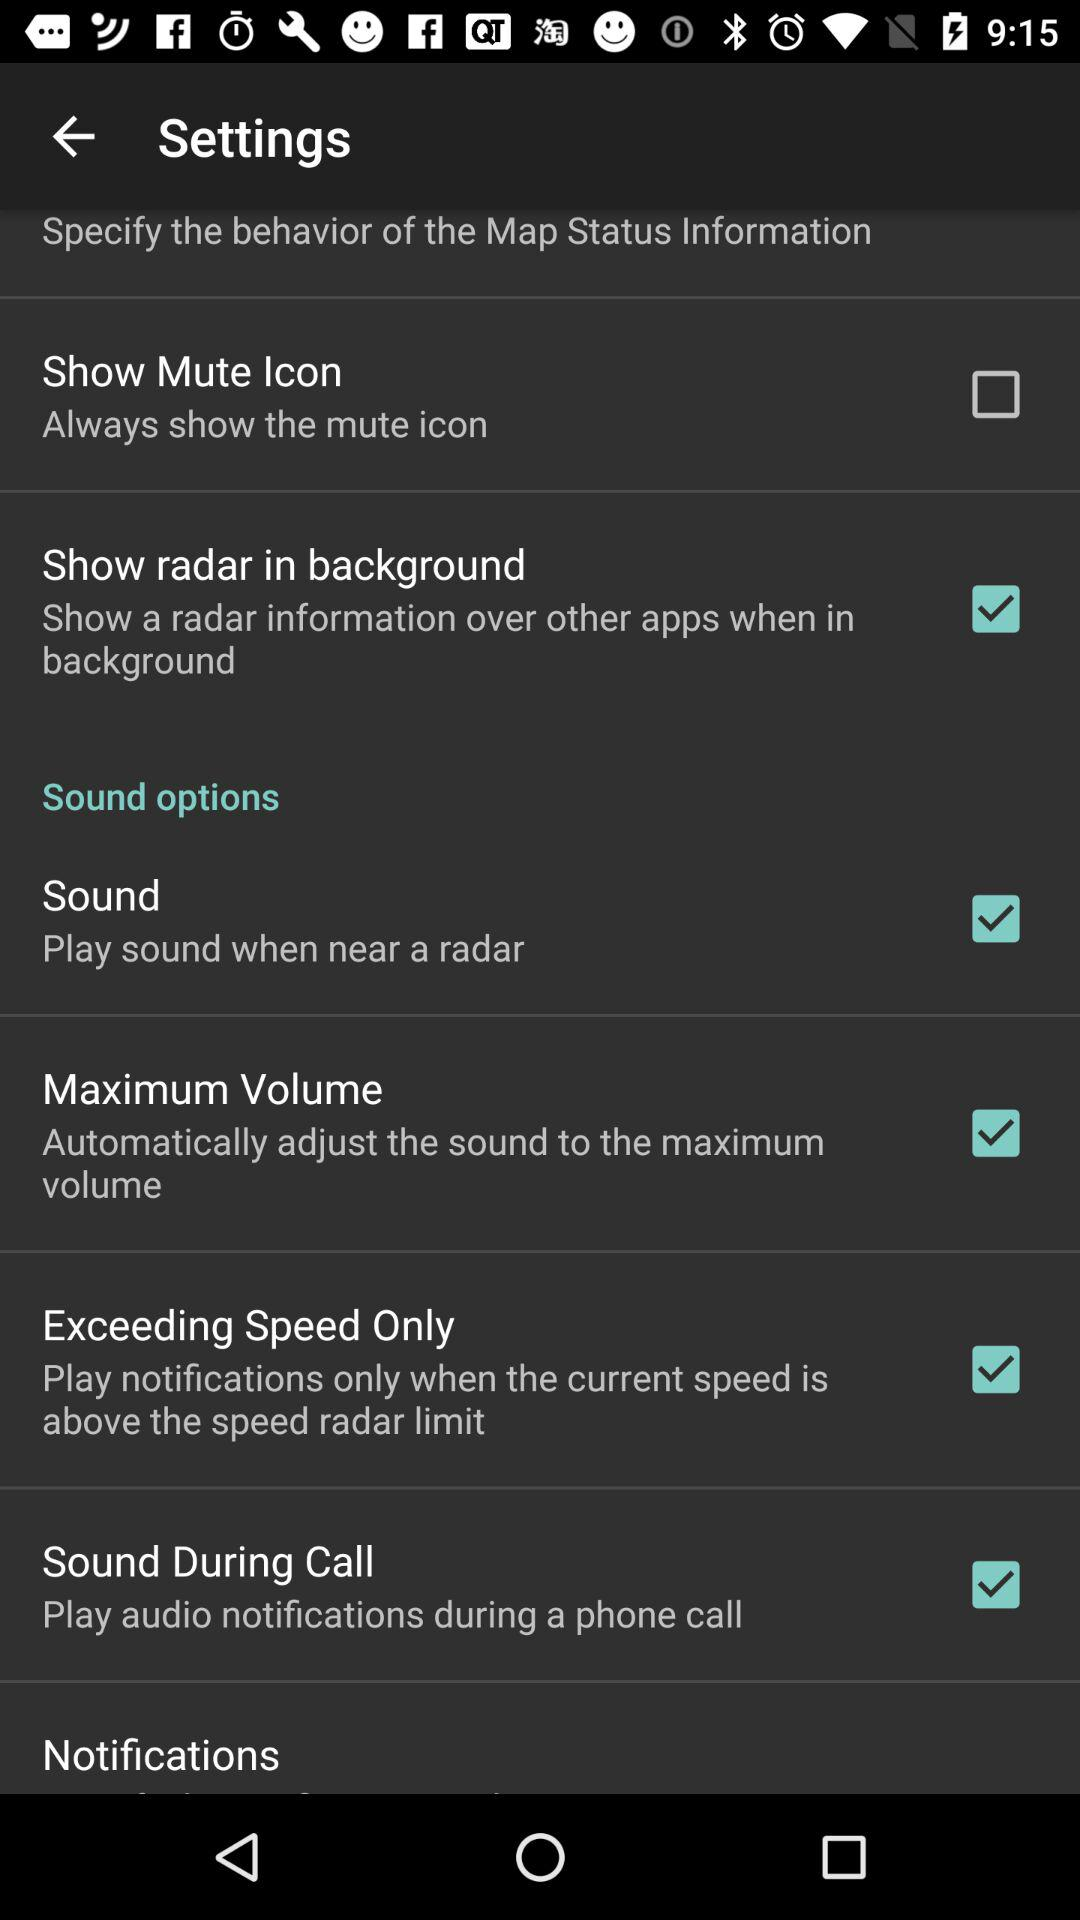What is the status of "Notifications"?
When the provided information is insufficient, respond with <no answer>. <no answer> 